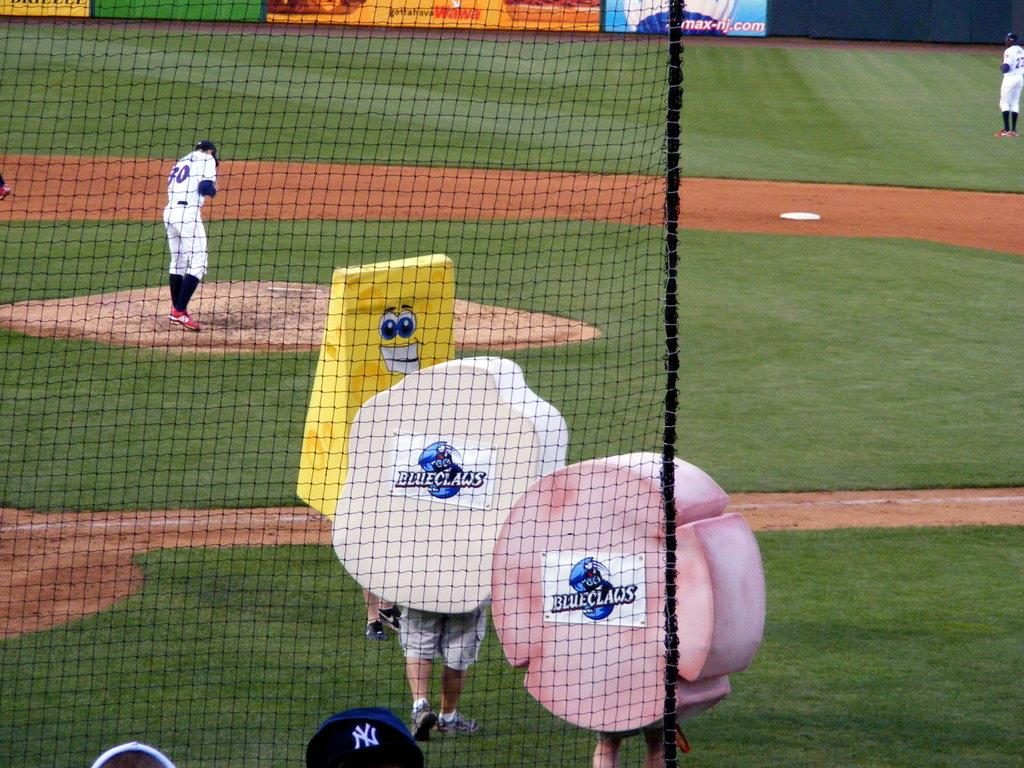<image>
Create a compact narrative representing the image presented. Two mascots are wearing Blue Claws posters on them 